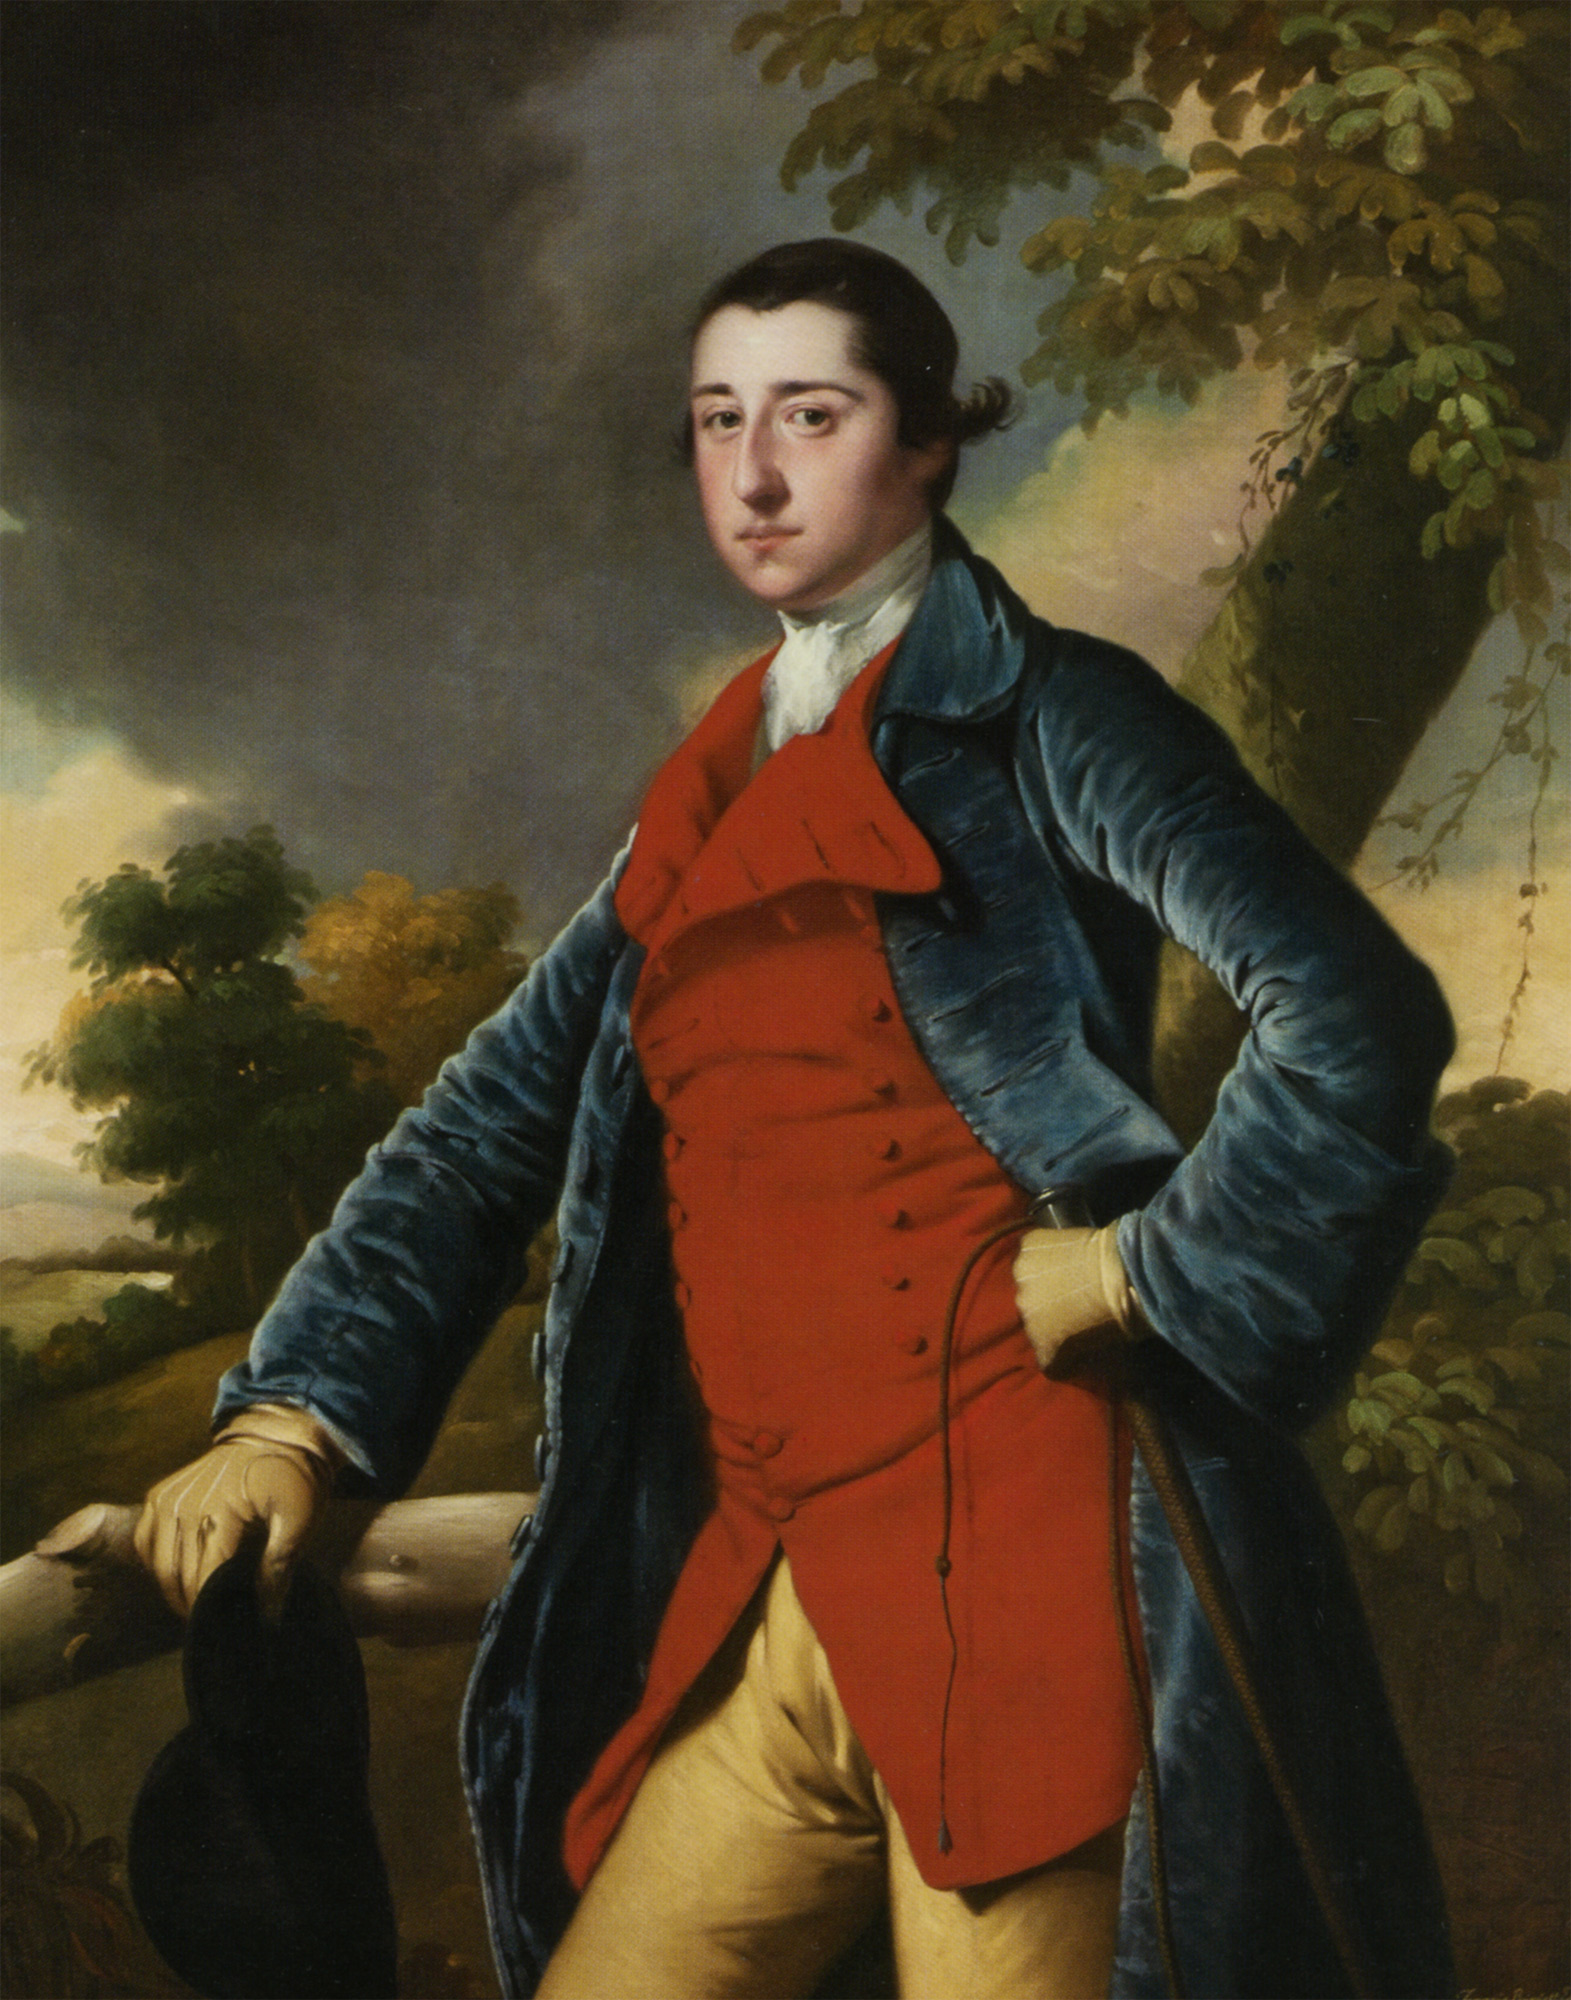What does the setting of the painting tell us about the subject? The landscape setting with lush trees and a distant horizon may symbolize the subject's connection to nature or his rural estates. This background, alongside the clear sky and the relaxed posture, could be used to communicate a sense of freedom or leisure that was idealized in portraits of this era, possibly reflecting the subject's personal life or aspirations. 